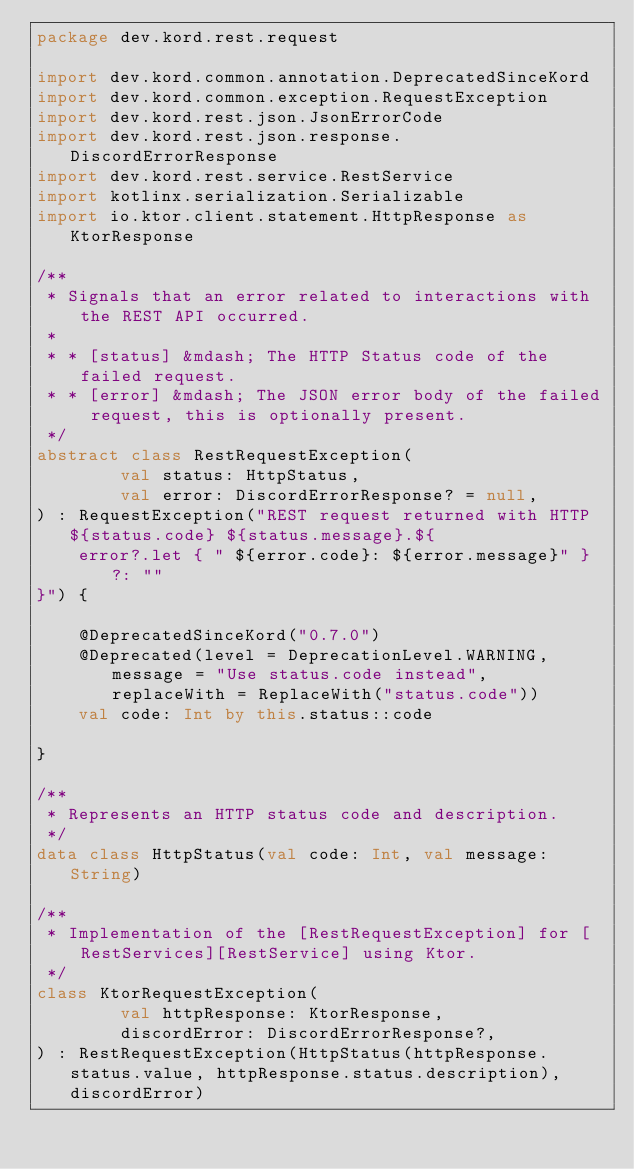Convert code to text. <code><loc_0><loc_0><loc_500><loc_500><_Kotlin_>package dev.kord.rest.request

import dev.kord.common.annotation.DeprecatedSinceKord
import dev.kord.common.exception.RequestException
import dev.kord.rest.json.JsonErrorCode
import dev.kord.rest.json.response.DiscordErrorResponse
import dev.kord.rest.service.RestService
import kotlinx.serialization.Serializable
import io.ktor.client.statement.HttpResponse as KtorResponse

/**
 * Signals that an error related to interactions with the REST API occurred.
 *
 * * [status] &mdash; The HTTP Status code of the failed request.
 * * [error] &mdash; The JSON error body of the failed request, this is optionally present.
 */
abstract class RestRequestException(
        val status: HttpStatus,
        val error: DiscordErrorResponse? = null,
) : RequestException("REST request returned with HTTP ${status.code} ${status.message}.${
    error?.let { " ${error.code}: ${error.message}" } ?: ""
}") {

    @DeprecatedSinceKord("0.7.0")
    @Deprecated(level = DeprecationLevel.WARNING, message = "Use status.code instead", replaceWith = ReplaceWith("status.code"))
    val code: Int by this.status::code

}

/**
 * Represents an HTTP status code and description.
 */
data class HttpStatus(val code: Int, val message: String)

/**
 * Implementation of the [RestRequestException] for [RestServices][RestService] using Ktor.
 */
class KtorRequestException(
        val httpResponse: KtorResponse,
        discordError: DiscordErrorResponse?,
) : RestRequestException(HttpStatus(httpResponse.status.value, httpResponse.status.description), discordError)</code> 